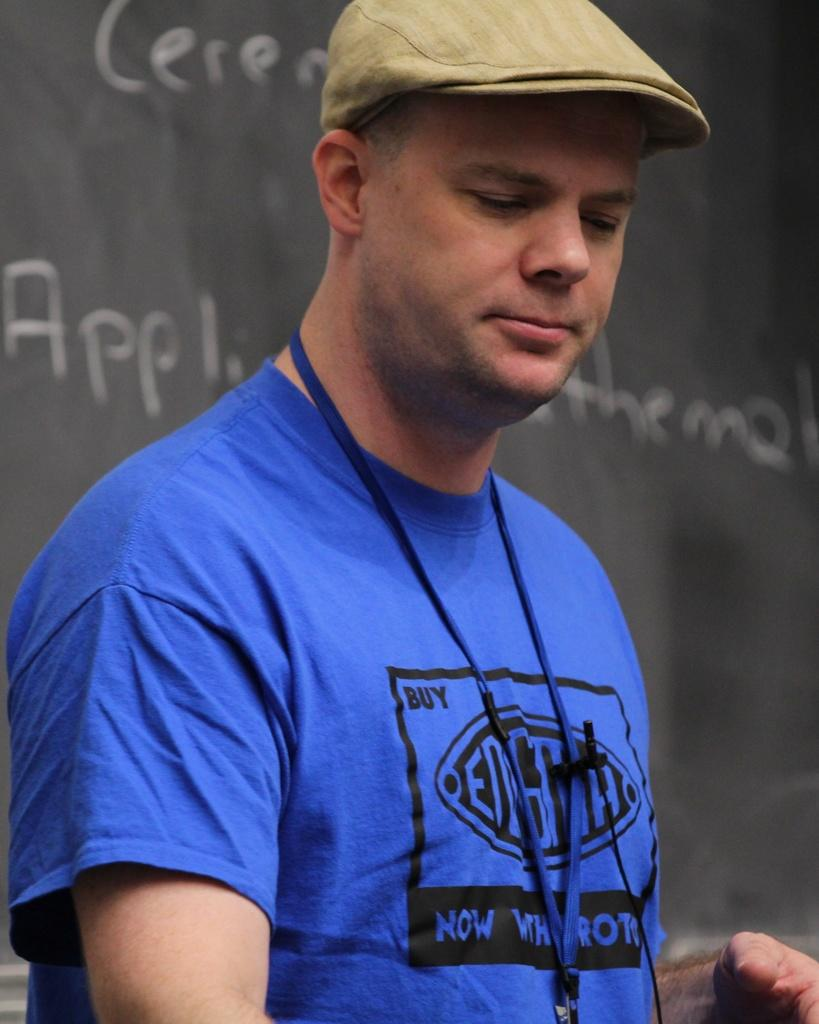<image>
Provide a brief description of the given image. A man wearing a blue shirt that says Buy and Now on it. 